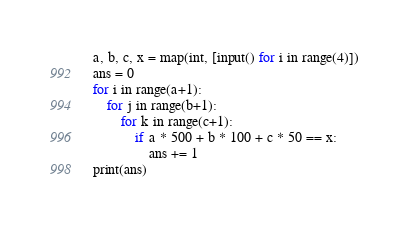Convert code to text. <code><loc_0><loc_0><loc_500><loc_500><_Python_>a, b, c, x = map(int, [input() for i in range(4)])
ans = 0
for i in range(a+1):
    for j in range(b+1):
        for k in range(c+1):
            if a * 500 + b * 100 + c * 50 == x:
                ans += 1
print(ans)</code> 